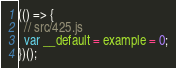<code> <loc_0><loc_0><loc_500><loc_500><_JavaScript_>(() => {
  // src/425.js
  var __default = example = 0;
})();
</code> 